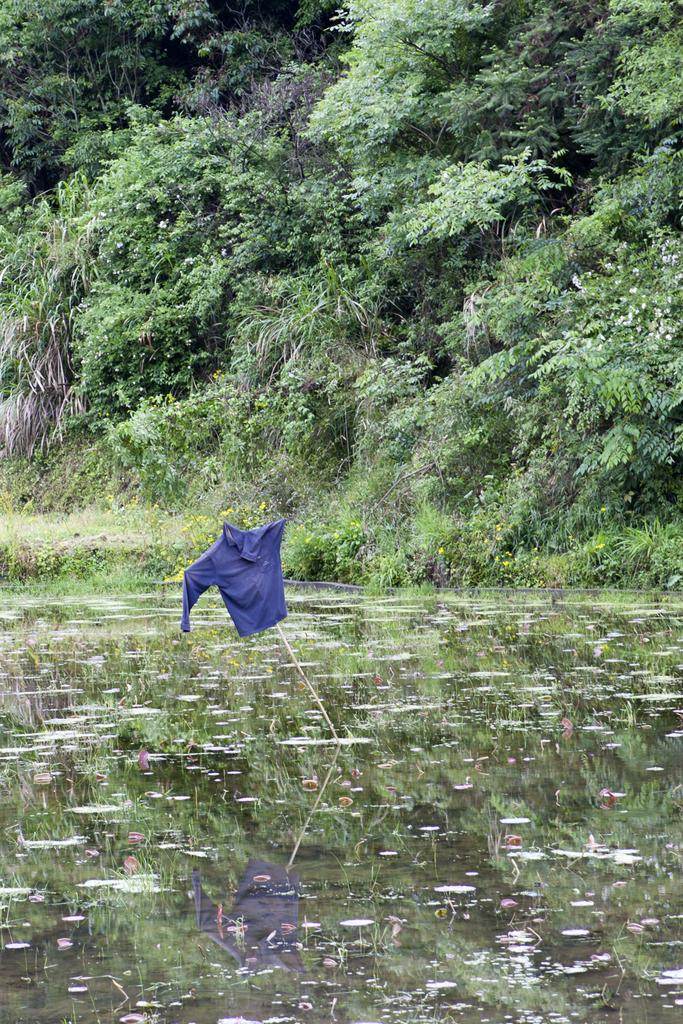Where was the image taken? The image was clicked outside. What can be seen at the bottom of the image? There is water at the bottom of the image. What is located in the middle of the image? There are trees in the middle of the image. What object is present in the image that is being used to hold something? There is a stick in the image, and a shirt is hanging on it. What type of record is being played in the image? There is no record present in the image. What is the cause of the trees in the image? The cause of the trees in the image is not mentioned, but they are likely a natural part of the environment. 